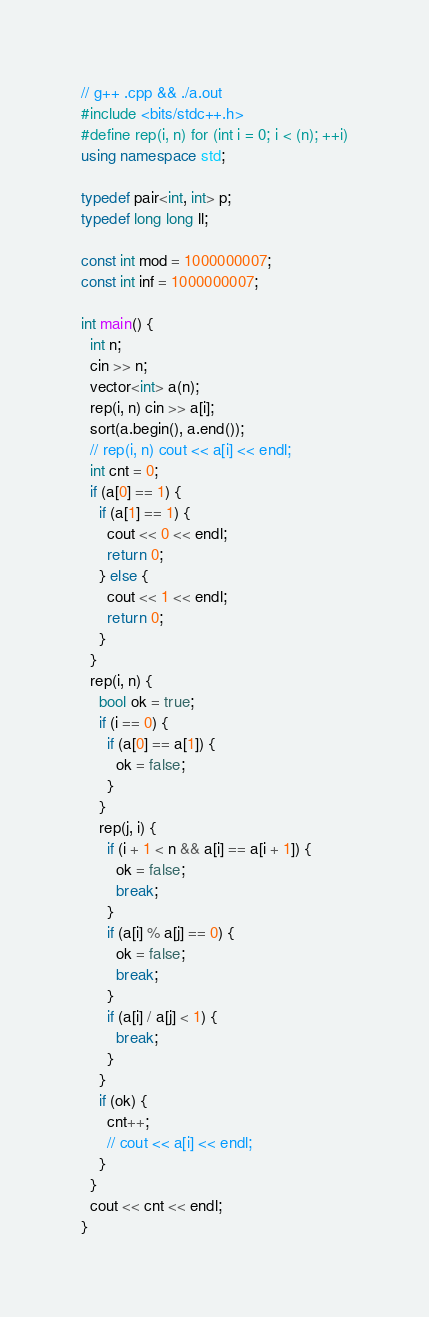Convert code to text. <code><loc_0><loc_0><loc_500><loc_500><_C++_>// g++ .cpp && ./a.out
#include <bits/stdc++.h>
#define rep(i, n) for (int i = 0; i < (n); ++i)
using namespace std;

typedef pair<int, int> p;
typedef long long ll;

const int mod = 1000000007;
const int inf = 1000000007;

int main() {
  int n;
  cin >> n;
  vector<int> a(n);
  rep(i, n) cin >> a[i];
  sort(a.begin(), a.end());
  // rep(i, n) cout << a[i] << endl;
  int cnt = 0;
  if (a[0] == 1) {
    if (a[1] == 1) {
      cout << 0 << endl;
      return 0;
    } else {
      cout << 1 << endl;
      return 0;
    }
  }
  rep(i, n) {
    bool ok = true;
    if (i == 0) {
      if (a[0] == a[1]) {
        ok = false;
      }
    }
    rep(j, i) {
      if (i + 1 < n && a[i] == a[i + 1]) {
        ok = false;
        break;
      }
      if (a[i] % a[j] == 0) {
        ok = false;
        break;
      }
      if (a[i] / a[j] < 1) {
        break;
      }
    }
    if (ok) {
      cnt++;
      // cout << a[i] << endl;
    }
  }
  cout << cnt << endl;
}
</code> 